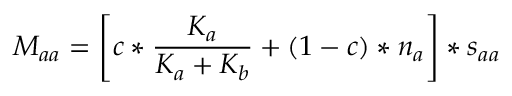<formula> <loc_0><loc_0><loc_500><loc_500>M _ { a a } = \left [ c * \frac { K _ { a } } { K _ { a } + K _ { b } } + ( 1 - c ) * n _ { a } \right ] * s _ { a a }</formula> 